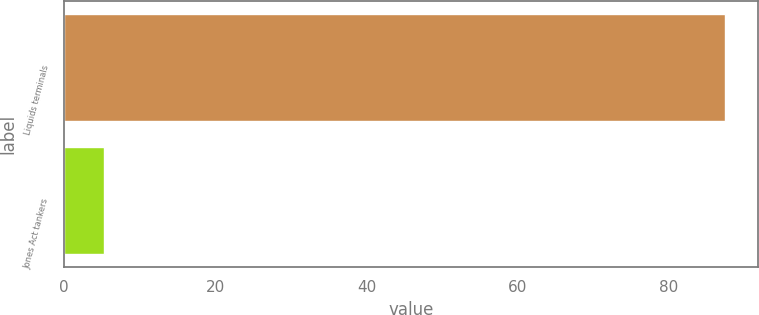Convert chart to OTSL. <chart><loc_0><loc_0><loc_500><loc_500><bar_chart><fcel>Liquids terminals<fcel>Jones Act tankers<nl><fcel>87.4<fcel>5.3<nl></chart> 